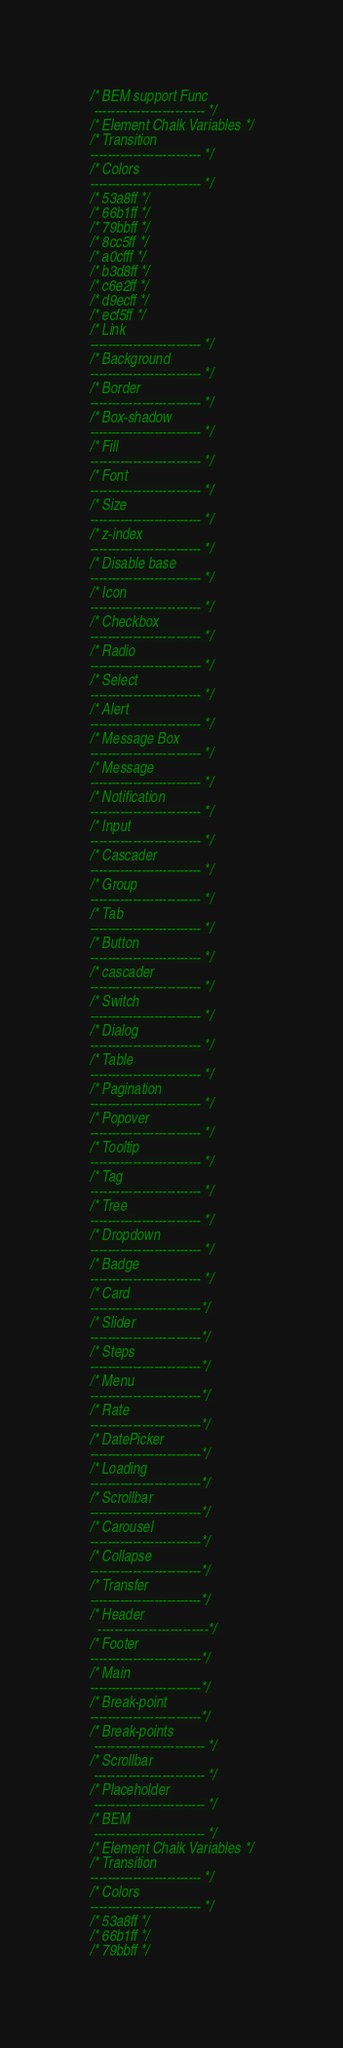Convert code to text. <code><loc_0><loc_0><loc_500><loc_500><_CSS_>/* BEM support Func
 -------------------------- */
/* Element Chalk Variables */
/* Transition
-------------------------- */
/* Colors
-------------------------- */
/* 53a8ff */
/* 66b1ff */
/* 79bbff */
/* 8cc5ff */
/* a0cfff */
/* b3d8ff */
/* c6e2ff */
/* d9ecff */
/* ecf5ff */
/* Link
-------------------------- */
/* Background
-------------------------- */
/* Border
-------------------------- */
/* Box-shadow
-------------------------- */
/* Fill
-------------------------- */
/* Font
-------------------------- */
/* Size
-------------------------- */
/* z-index
-------------------------- */
/* Disable base
-------------------------- */
/* Icon
-------------------------- */
/* Checkbox
-------------------------- */
/* Radio
-------------------------- */
/* Select
-------------------------- */
/* Alert
-------------------------- */
/* Message Box
-------------------------- */
/* Message
-------------------------- */
/* Notification
-------------------------- */
/* Input
-------------------------- */
/* Cascader
-------------------------- */
/* Group
-------------------------- */
/* Tab
-------------------------- */
/* Button
-------------------------- */
/* cascader
-------------------------- */
/* Switch
-------------------------- */
/* Dialog
-------------------------- */
/* Table
-------------------------- */
/* Pagination
-------------------------- */
/* Popover
-------------------------- */
/* Tooltip
-------------------------- */
/* Tag
-------------------------- */
/* Tree
-------------------------- */
/* Dropdown
-------------------------- */
/* Badge
-------------------------- */
/* Card
--------------------------*/
/* Slider
--------------------------*/
/* Steps
--------------------------*/
/* Menu
--------------------------*/
/* Rate
--------------------------*/
/* DatePicker
--------------------------*/
/* Loading
--------------------------*/
/* Scrollbar
--------------------------*/
/* Carousel
--------------------------*/
/* Collapse
--------------------------*/
/* Transfer
--------------------------*/
/* Header
  --------------------------*/
/* Footer
--------------------------*/
/* Main
--------------------------*/
/* Break-point
--------------------------*/
/* Break-points
 -------------------------- */
/* Scrollbar
 -------------------------- */
/* Placeholder
 -------------------------- */
/* BEM
 -------------------------- */
/* Element Chalk Variables */
/* Transition
-------------------------- */
/* Colors
-------------------------- */
/* 53a8ff */
/* 66b1ff */
/* 79bbff */</code> 